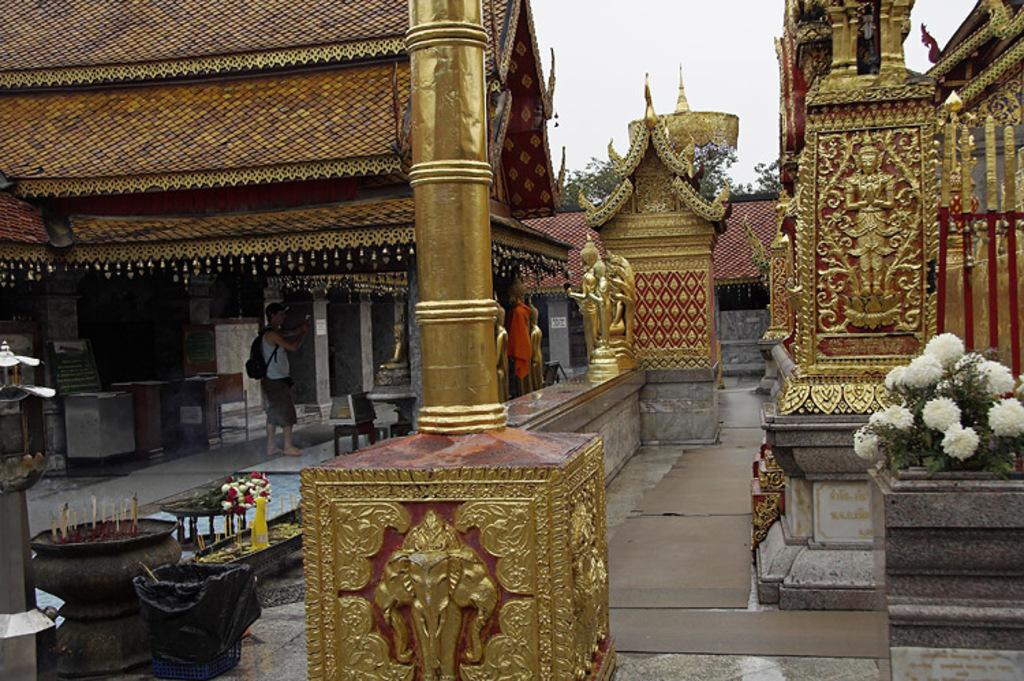What type of structure is shown in the image? The image depicts a temple. Can you describe the interior of the temple? There is a man inside the temple. What architectural features are present in the temple? There are pillars in the temple. Are there any decorative elements in the temple? Yes, there are statues in the temple. What can be seen on the right side of the image? There is a flower pot on the right side of the image. How does the temple contribute to pollution in the area? The image does not provide any information about pollution, and the temple itself is not a source of pollution. 